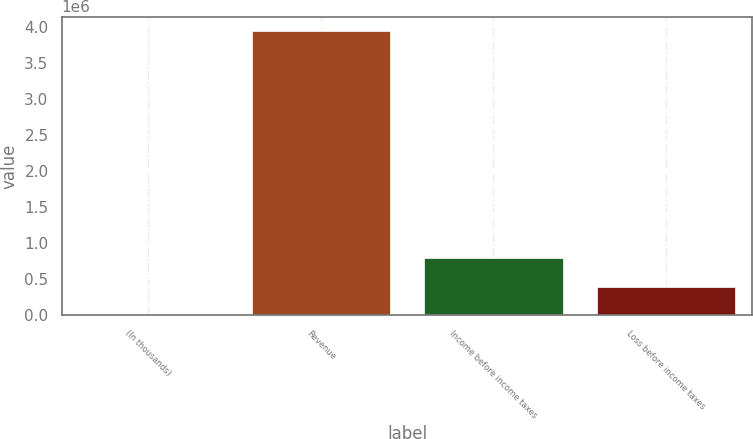Convert chart. <chart><loc_0><loc_0><loc_500><loc_500><bar_chart><fcel>(In thousands)<fcel>Revenue<fcel>Income before income taxes<fcel>Loss before income taxes<nl><fcel>2012<fcel>3.94494e+06<fcel>790598<fcel>396305<nl></chart> 